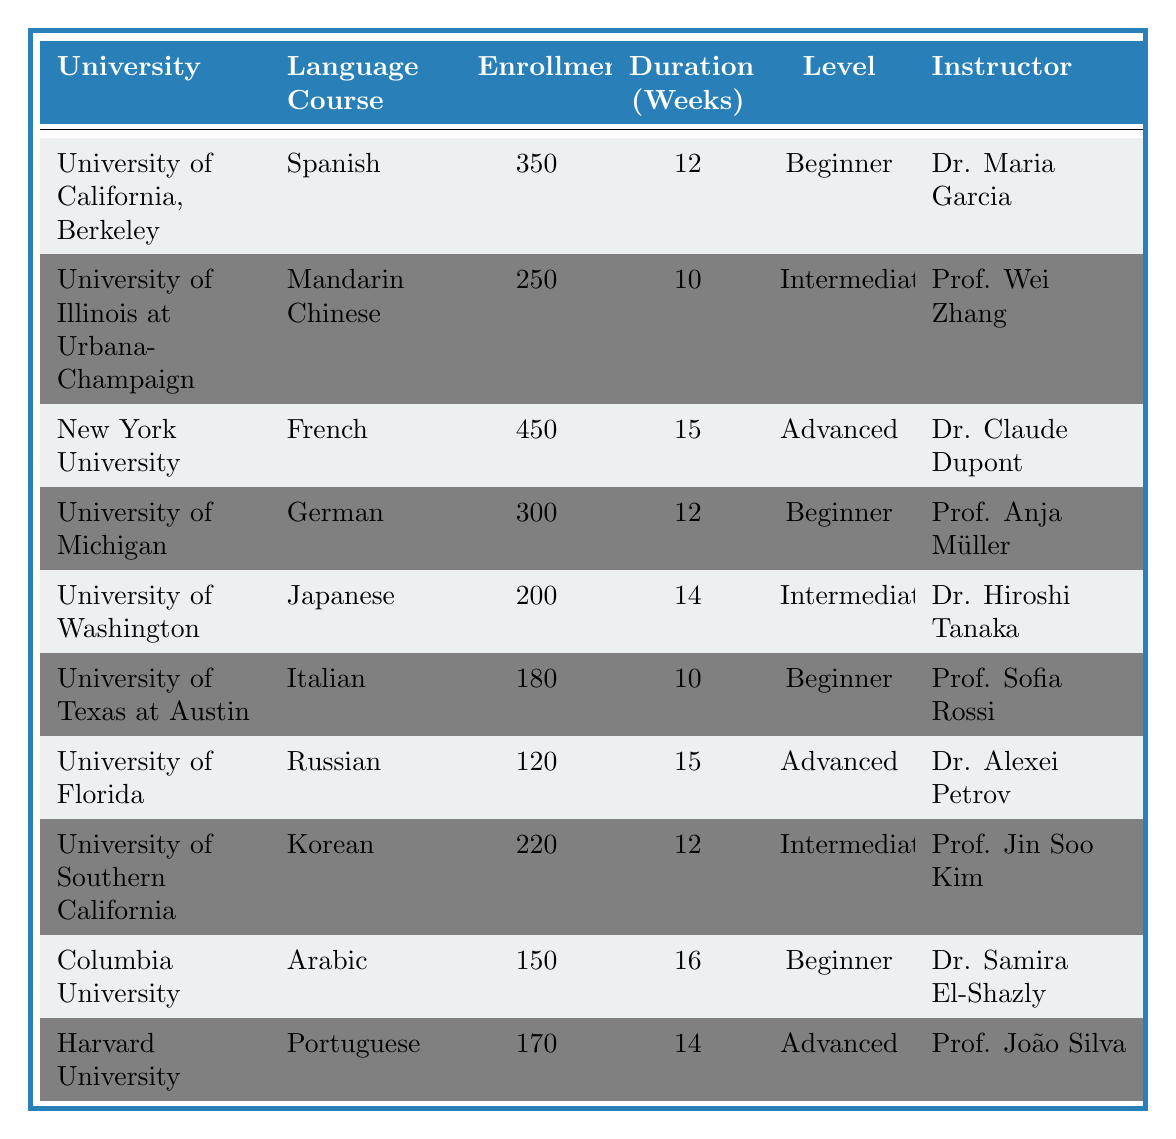What is the highest enrollment in the language courses listed? The table shows the language course with the highest enrollment is French at New York University with an enrollment of 450.
Answer: 450 Which university offers Spanish language courses? According to the table, Spanish is offered at the University of California, Berkeley.
Answer: University of California, Berkeley What is the average enrollment of beginner-level language courses? To find the average, we take the enrollments of the beginner courses: 350 (Spanish) + 300 (German) + 180 (Italian) + 150 (Arabic) = 980. There are four beginner courses, so the average is 980 / 4 = 245.
Answer: 245 Does Harvard University offer an intermediate-level language course? Checking the table, Harvard University does not have an intermediate-level course; it offers a Portuguese course at an advanced level.
Answer: No How many universities offer advanced language courses, and what are the languages? From the table, there are three advanced courses: French at New York University, Russian at the University of Florida, and Portuguese at Harvard University, making it three universities offering advanced courses.
Answer: Three; French, Russian, Portuguese What is the total enrollment for the intermediate-level language courses? The intermediate courses listed are Mandarin Chinese with 250, Japanese with 200, and Korean with 220. The total enrollment is 250 + 200 + 220 = 670.
Answer: 670 Which instructor teaches the German course? Referring to the table, the German course is taught by Professor Anja Müller at the University of Michigan.
Answer: Prof. Anja Müller Is the duration of the Arabic language course longer than the duration of the Japanese course? Comparing durations from the table, the Arabic course is 16 weeks, and the Japanese course is 14 weeks. Thus, the Arabic course is indeed longer.
Answer: Yes What percentage of the total enrollment is accounted for by the French language course? The total enrollment is 350 + 250 + 450 + 300 + 200 + 180 + 120 + 220 + 150 + 170 = 2,420. The French course enrollment is 450, so the percentage is (450 / 2420) * 100 = 18.6%.
Answer: 18.6% Which language course has the shortest duration, and how long is it? In the table, both Mandarin Chinese and Italian have durations of 10 weeks, which are the shortest compared to other courses.
Answer: Mandarin Chinese and Italian; 10 weeks 